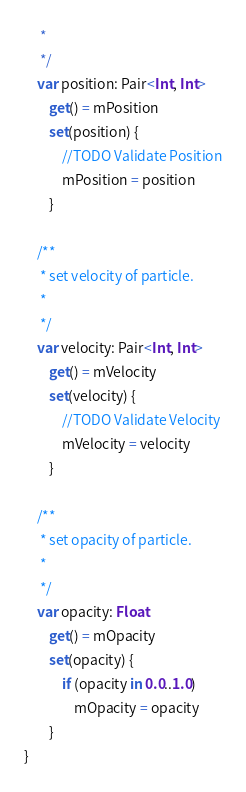Convert code to text. <code><loc_0><loc_0><loc_500><loc_500><_Kotlin_>     *
     */
    var position: Pair<Int, Int>
        get() = mPosition
        set(position) {
            //TODO Validate Position
            mPosition = position
        }

    /**
     * set velocity of particle.
     *
     */
    var velocity: Pair<Int, Int>
        get() = mVelocity
        set(velocity) {
            //TODO Validate Velocity
            mVelocity = velocity
        }

    /**
     * set opacity of particle.
     *
     */
    var opacity: Float
        get() = mOpacity
        set(opacity) {
            if (opacity in 0.0..1.0)
                mOpacity = opacity
        }
}</code> 